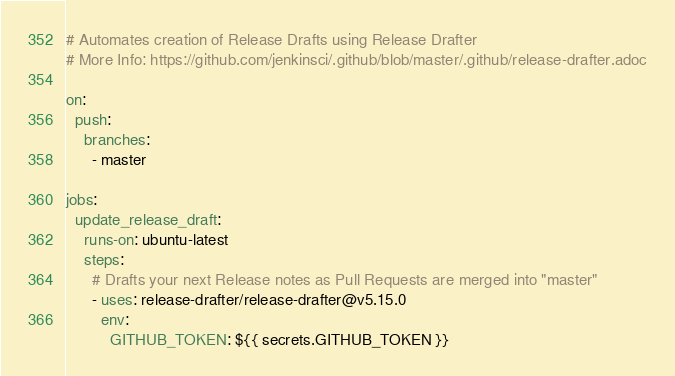<code> <loc_0><loc_0><loc_500><loc_500><_YAML_># Automates creation of Release Drafts using Release Drafter
# More Info: https://github.com/jenkinsci/.github/blob/master/.github/release-drafter.adoc

on:
  push:
    branches:
      - master

jobs:
  update_release_draft:
    runs-on: ubuntu-latest
    steps:
      # Drafts your next Release notes as Pull Requests are merged into "master"
      - uses: release-drafter/release-drafter@v5.15.0
        env:
          GITHUB_TOKEN: ${{ secrets.GITHUB_TOKEN }}
</code> 